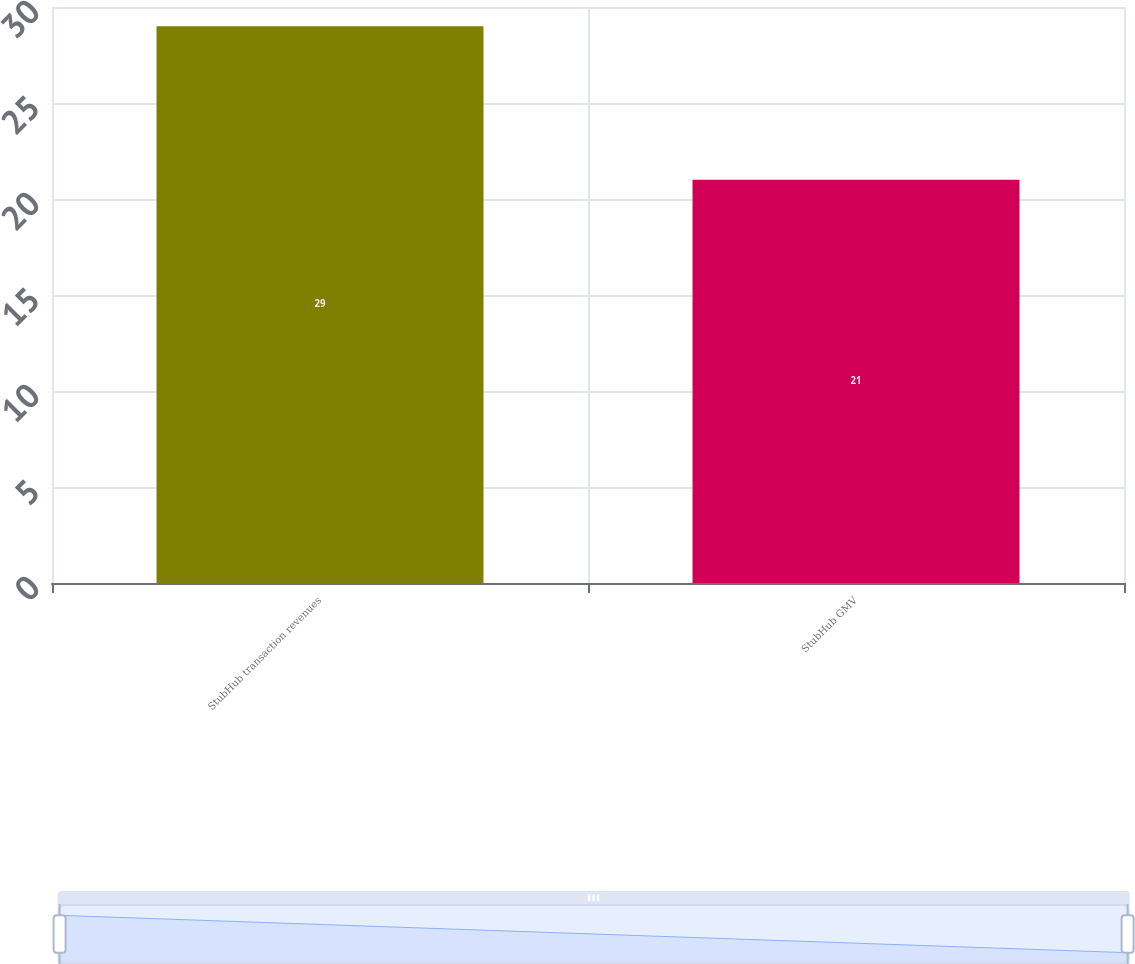<chart> <loc_0><loc_0><loc_500><loc_500><bar_chart><fcel>StubHub transaction revenues<fcel>StubHub GMV<nl><fcel>29<fcel>21<nl></chart> 